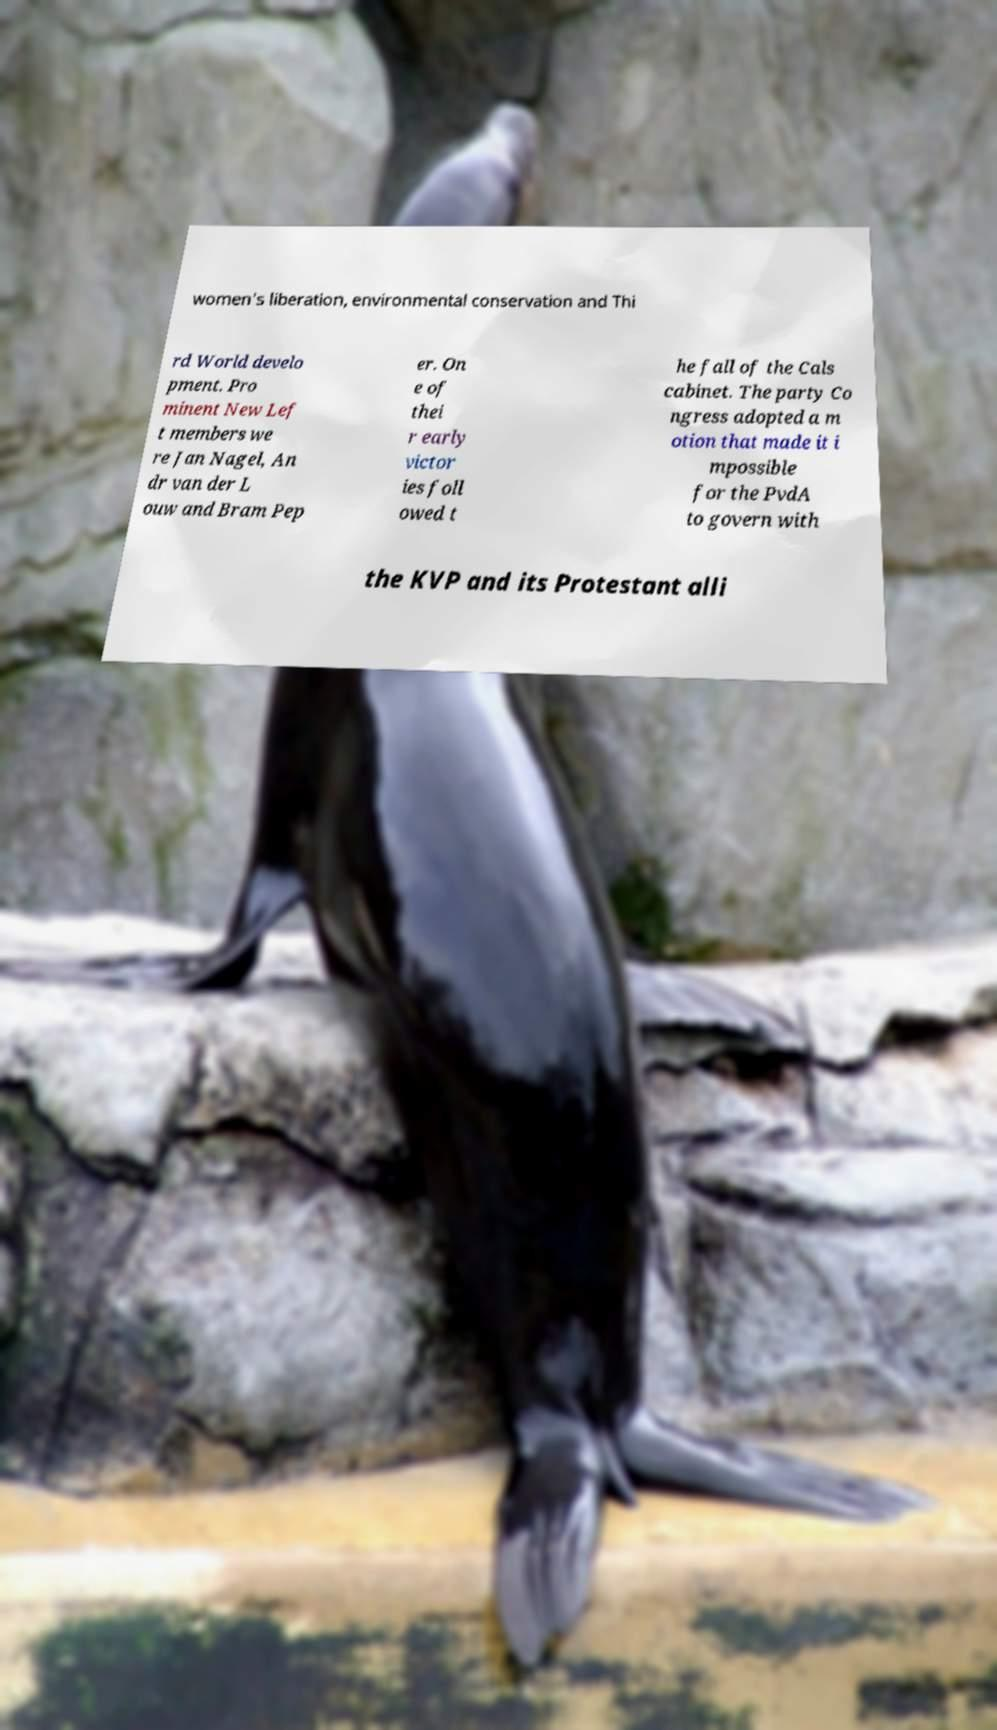Please identify and transcribe the text found in this image. women's liberation, environmental conservation and Thi rd World develo pment. Pro minent New Lef t members we re Jan Nagel, An dr van der L ouw and Bram Pep er. On e of thei r early victor ies foll owed t he fall of the Cals cabinet. The party Co ngress adopted a m otion that made it i mpossible for the PvdA to govern with the KVP and its Protestant alli 